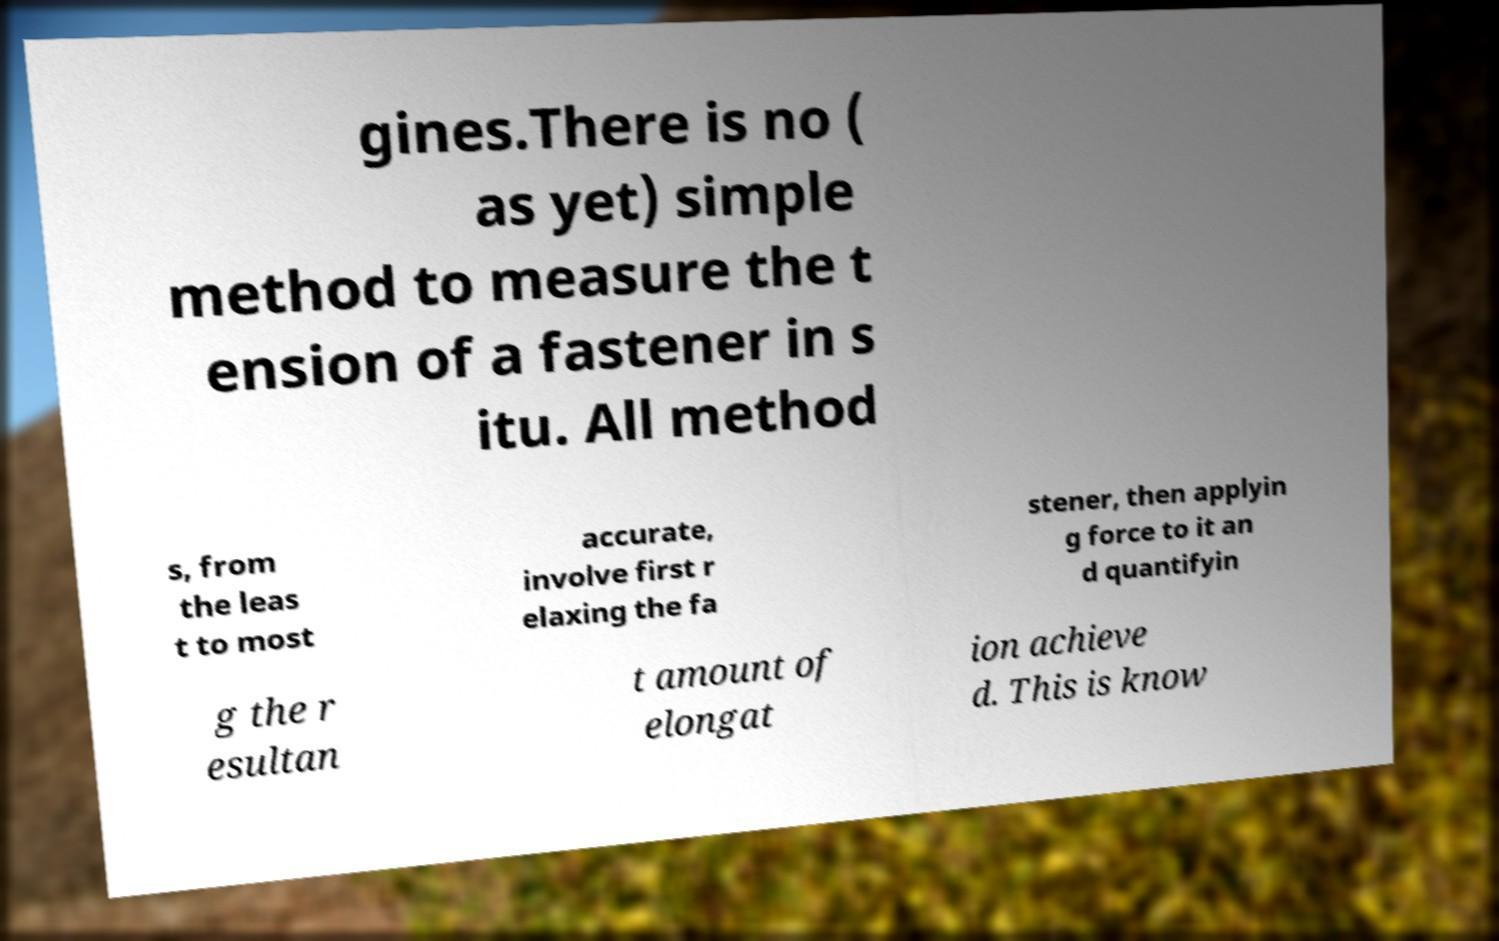Please read and relay the text visible in this image. What does it say? gines.There is no ( as yet) simple method to measure the t ension of a fastener in s itu. All method s, from the leas t to most accurate, involve first r elaxing the fa stener, then applyin g force to it an d quantifyin g the r esultan t amount of elongat ion achieve d. This is know 